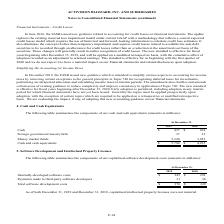According to Activision Blizzard's financial document, What were the Internally-developed software costs in 2019? According to the financial document, 345 (in millions). The relevant text states: "Internally-developed software costs $ 345 $ 291..." Also, What was the amounts of Payments made to third-party software developers in 2019? According to the financial document, 31 (in millions). The relevant text states: "At December 31,..." Also, What was the total software development costs in 2018? According to the financial document, 329 (in millions). The relevant text states: "Total software development costs $ 376 $ 329..." Also, can you calculate: What was the change in Internally-developed software costs between 2018 and 2019? Based on the calculation: $345-$291, the result is 54 (in millions). This is based on the information: "Internally-developed software costs $ 345 $ 291 Internally-developed software costs $ 345 $ 291..." The key data points involved are: 291, 345. Also, can you calculate: What was the change in payments made to third-party software developers between 2018 and 2019? Based on the calculation: 31-38, the result is -7 (in millions). This is based on the information: "yments made to third-party software developers 31 38 Payments made to third-party software developers 31 38..." The key data points involved are: 31, 38. Also, can you calculate: What was the percentage change in total software development costs between 2018 and 2019? To answer this question, I need to perform calculations using the financial data. The calculation is: ($376-$329)/$329, which equals 14.29 (percentage). This is based on the information: "Total software development costs $ 376 $ 329 Total software development costs $ 376 $ 329..." The key data points involved are: 329, 376. 